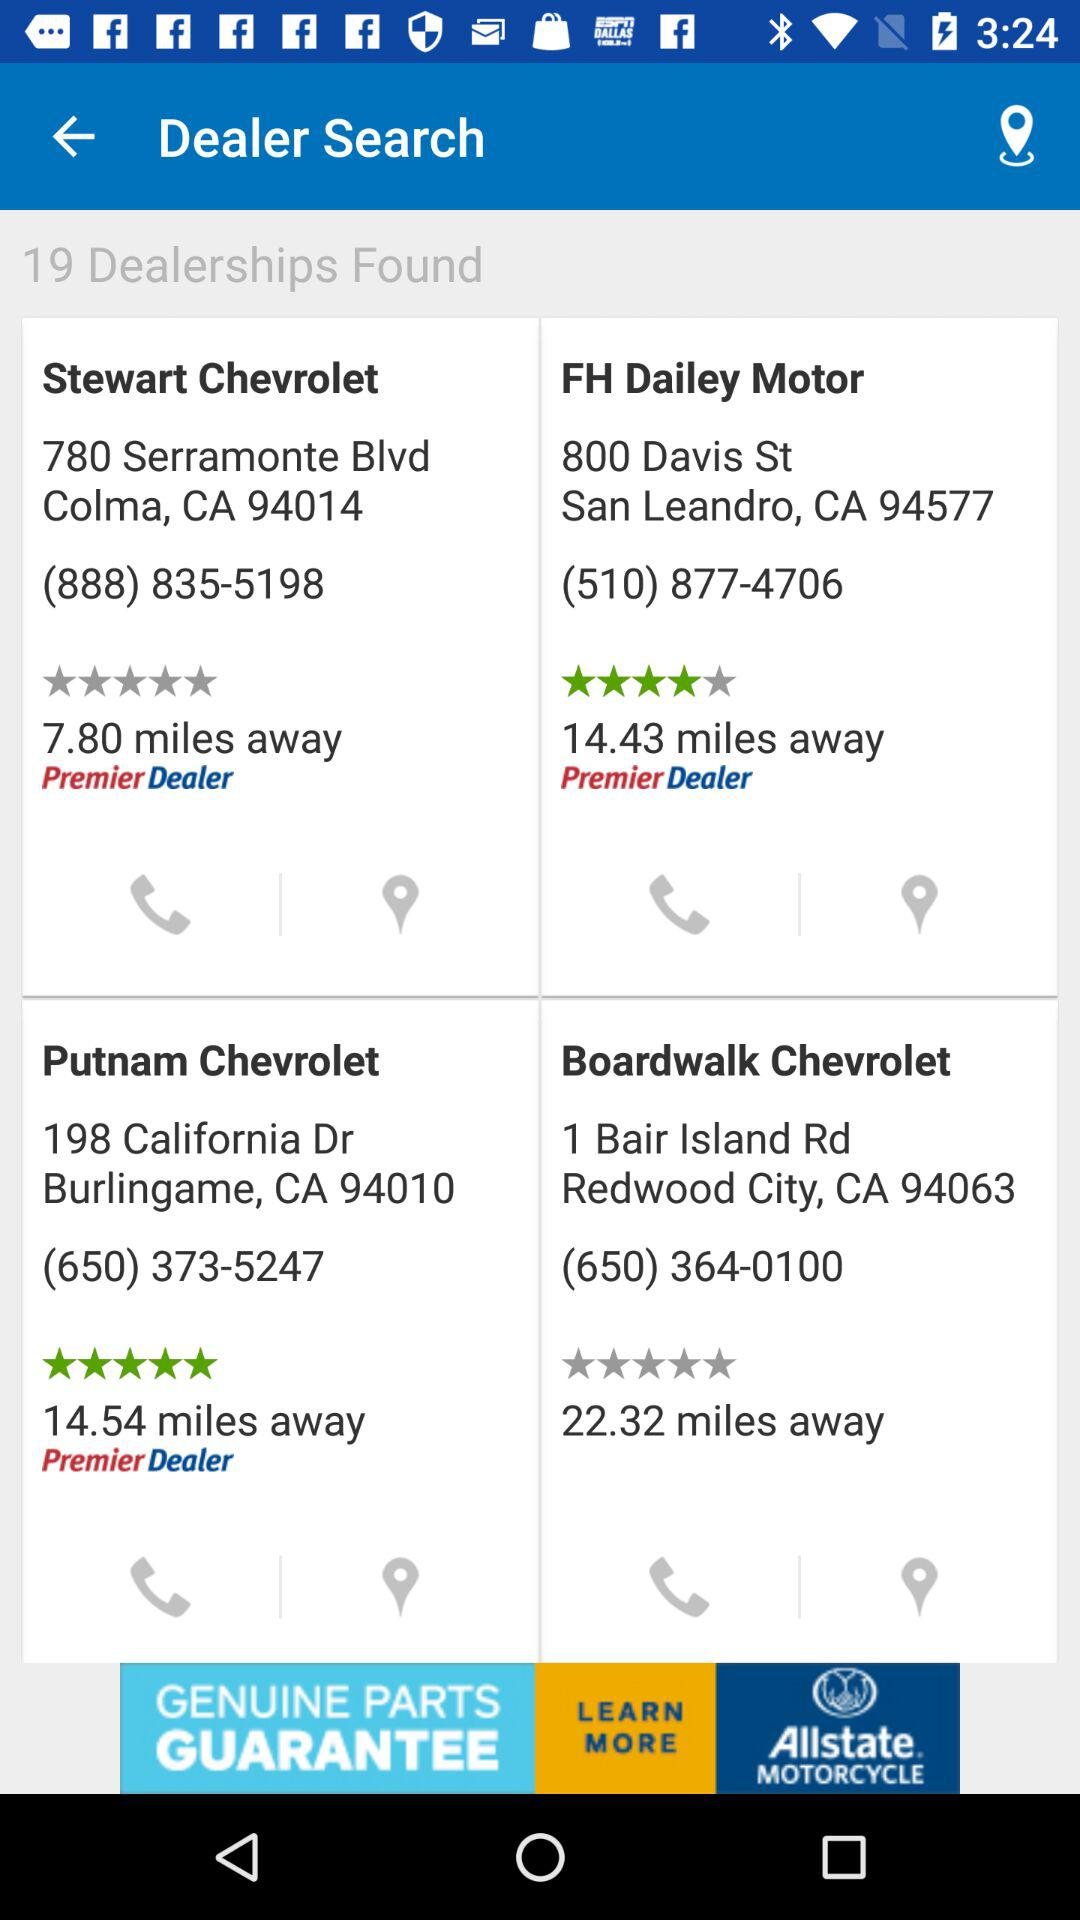What is the address of "FH Daily Motor"? The address of "FH Daily Motor" is 800 Davis St., San Leandro, CA 94577. 